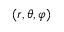<formula> <loc_0><loc_0><loc_500><loc_500>( r , \theta , \varphi )</formula> 